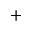Convert formula to latex. <formula><loc_0><loc_0><loc_500><loc_500>^ { + }</formula> 